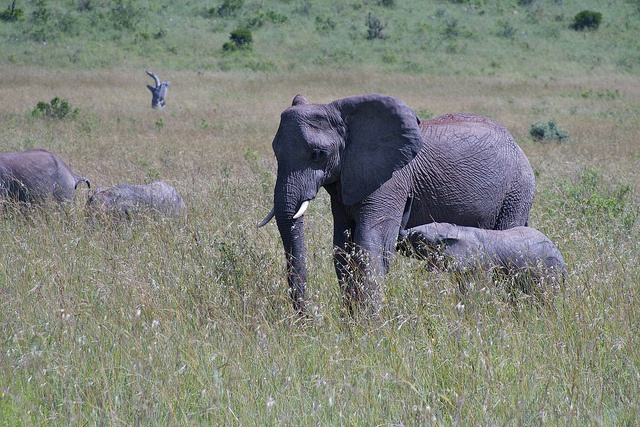Describe the objects in this image and their specific colors. I can see elephant in gray, black, and darkgray tones, elephant in gray and darkgray tones, elephant in gray, black, and darkgray tones, elephant in gray tones, and elephant in gray and darkgray tones in this image. 